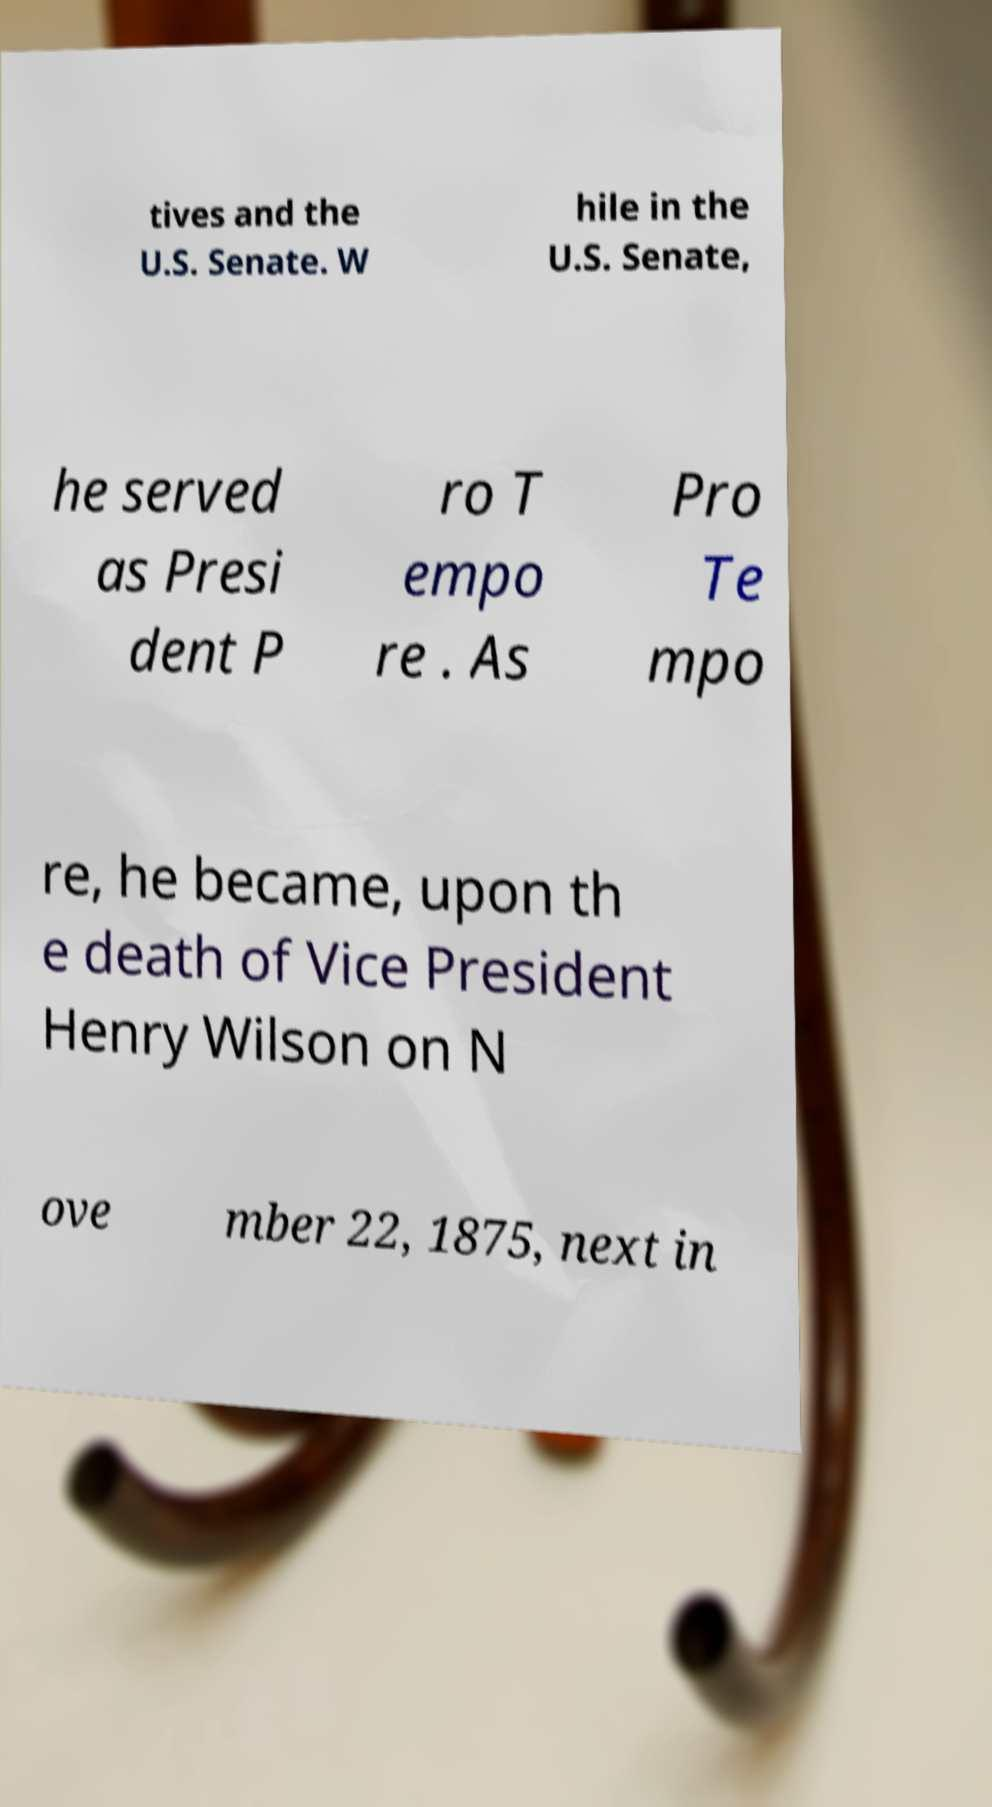Please read and relay the text visible in this image. What does it say? tives and the U.S. Senate. W hile in the U.S. Senate, he served as Presi dent P ro T empo re . As Pro Te mpo re, he became, upon th e death of Vice President Henry Wilson on N ove mber 22, 1875, next in 